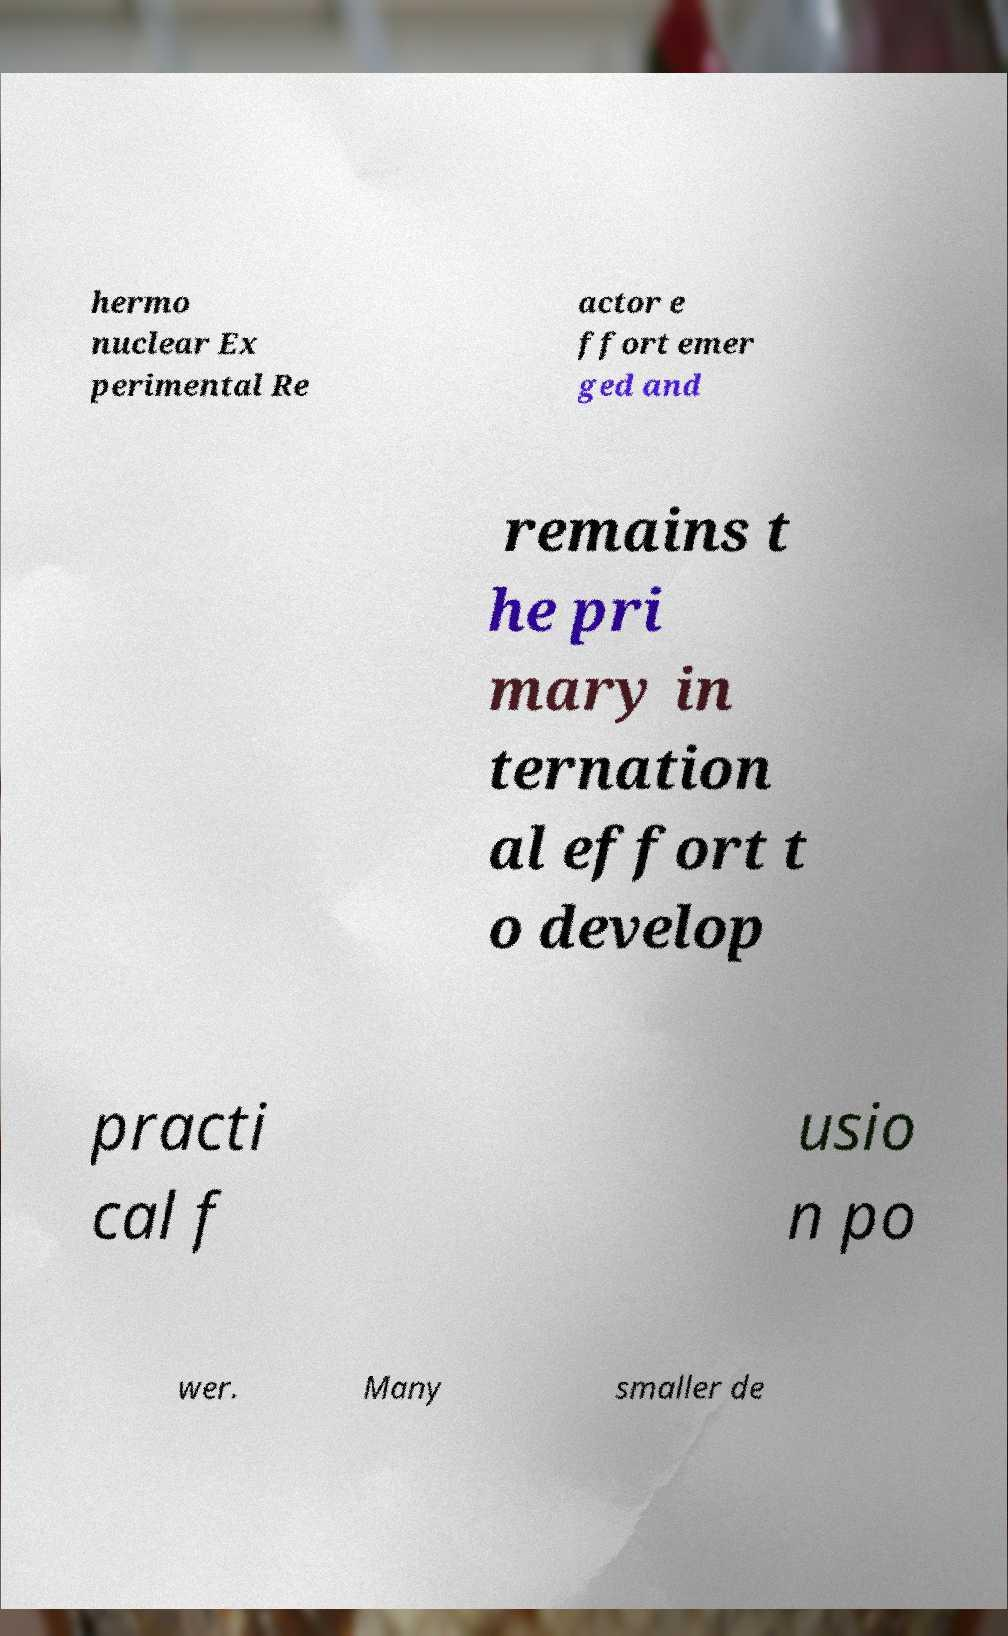Can you read and provide the text displayed in the image?This photo seems to have some interesting text. Can you extract and type it out for me? hermo nuclear Ex perimental Re actor e ffort emer ged and remains t he pri mary in ternation al effort t o develop practi cal f usio n po wer. Many smaller de 